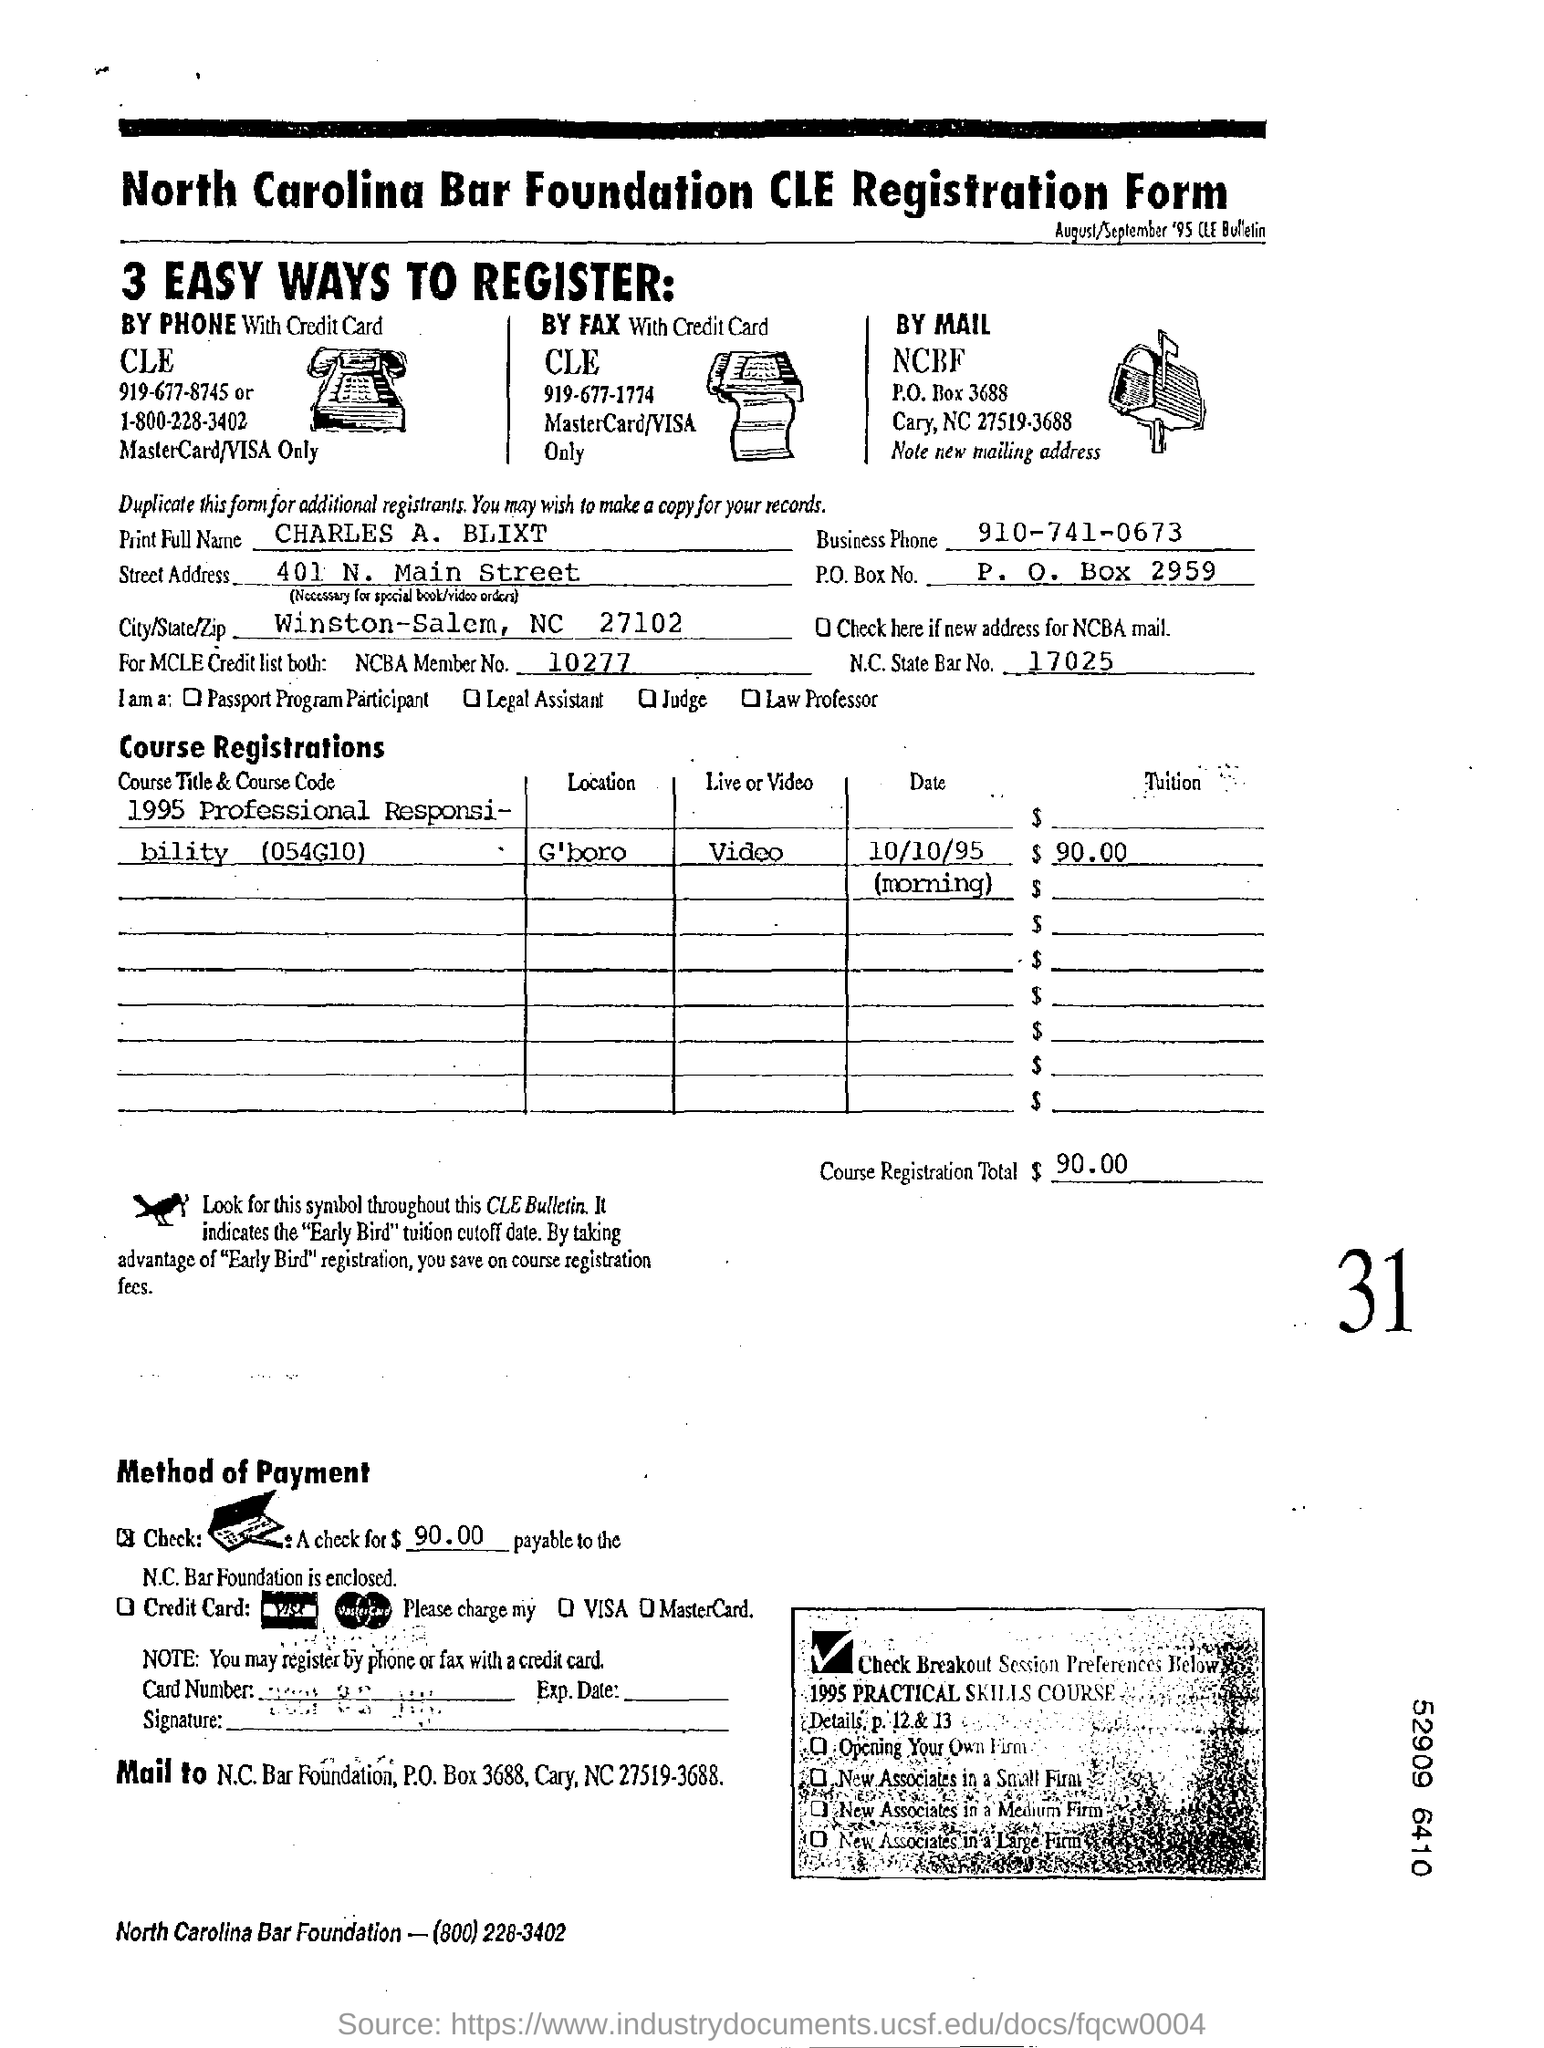How many ways are mentioned to register?
Provide a succinct answer. 3. What is the NCBA member number?
Your response must be concise. 10277. What is the mode of payment?
Your answer should be very brief. Check. What is the name of the foundation?
Give a very brief answer. North Carolina bar foundation. 